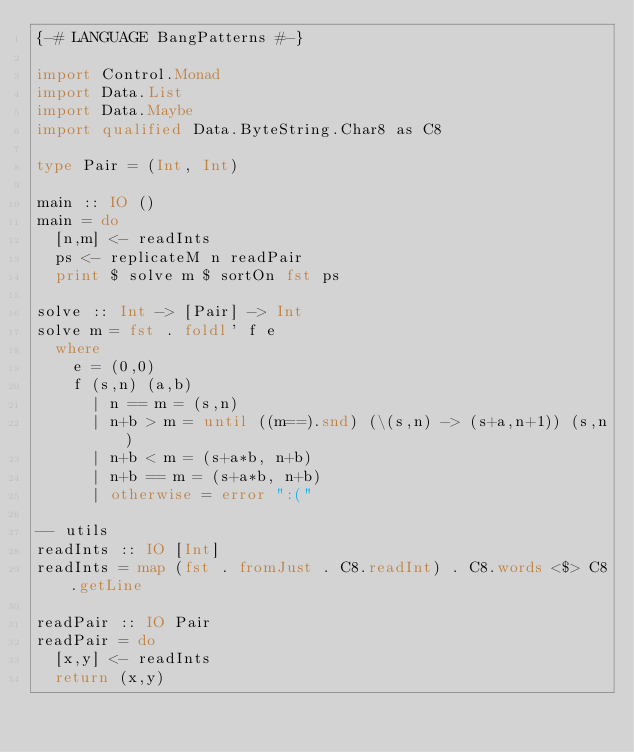<code> <loc_0><loc_0><loc_500><loc_500><_Haskell_>{-# LANGUAGE BangPatterns #-}

import Control.Monad
import Data.List
import Data.Maybe
import qualified Data.ByteString.Char8 as C8

type Pair = (Int, Int)

main :: IO ()
main = do
  [n,m] <- readInts
  ps <- replicateM n readPair
  print $ solve m $ sortOn fst ps
 
solve :: Int -> [Pair] -> Int
solve m = fst . foldl' f e
  where
    e = (0,0)
    f (s,n) (a,b)
      | n == m = (s,n)
      | n+b > m = until ((m==).snd) (\(s,n) -> (s+a,n+1)) (s,n)
      | n+b < m = (s+a*b, n+b)
      | n+b == m = (s+a*b, n+b)
      | otherwise = error ":("

-- utils
readInts :: IO [Int]
readInts = map (fst . fromJust . C8.readInt) . C8.words <$> C8.getLine

readPair :: IO Pair
readPair = do
  [x,y] <- readInts
  return (x,y)</code> 